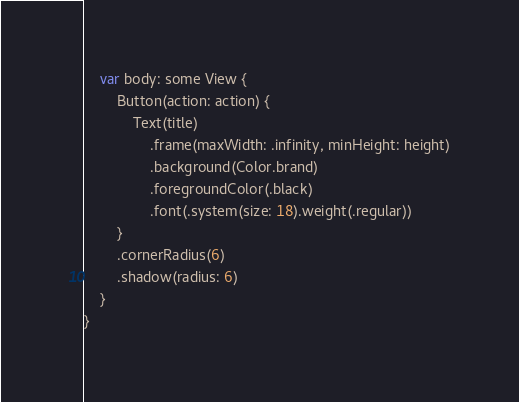Convert code to text. <code><loc_0><loc_0><loc_500><loc_500><_Swift_>    var body: some View {
        Button(action: action) {
            Text(title)
                .frame(maxWidth: .infinity, minHeight: height)
                .background(Color.brand)
                .foregroundColor(.black)
                .font(.system(size: 18).weight(.regular))
        }
        .cornerRadius(6)
        .shadow(radius: 6)
    }
}
</code> 